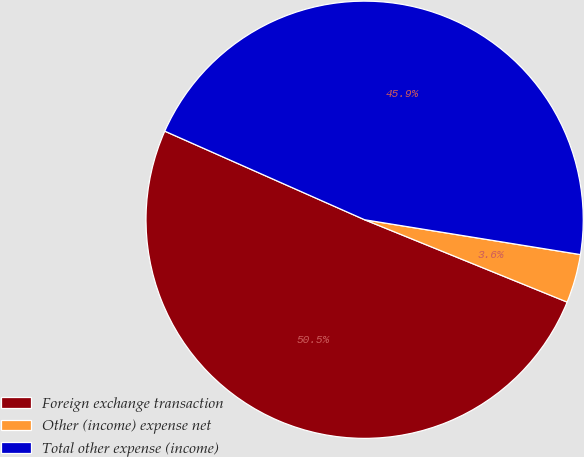Convert chart. <chart><loc_0><loc_0><loc_500><loc_500><pie_chart><fcel>Foreign exchange transaction<fcel>Other (income) expense net<fcel>Total other expense (income)<nl><fcel>50.5%<fcel>3.6%<fcel>45.91%<nl></chart> 